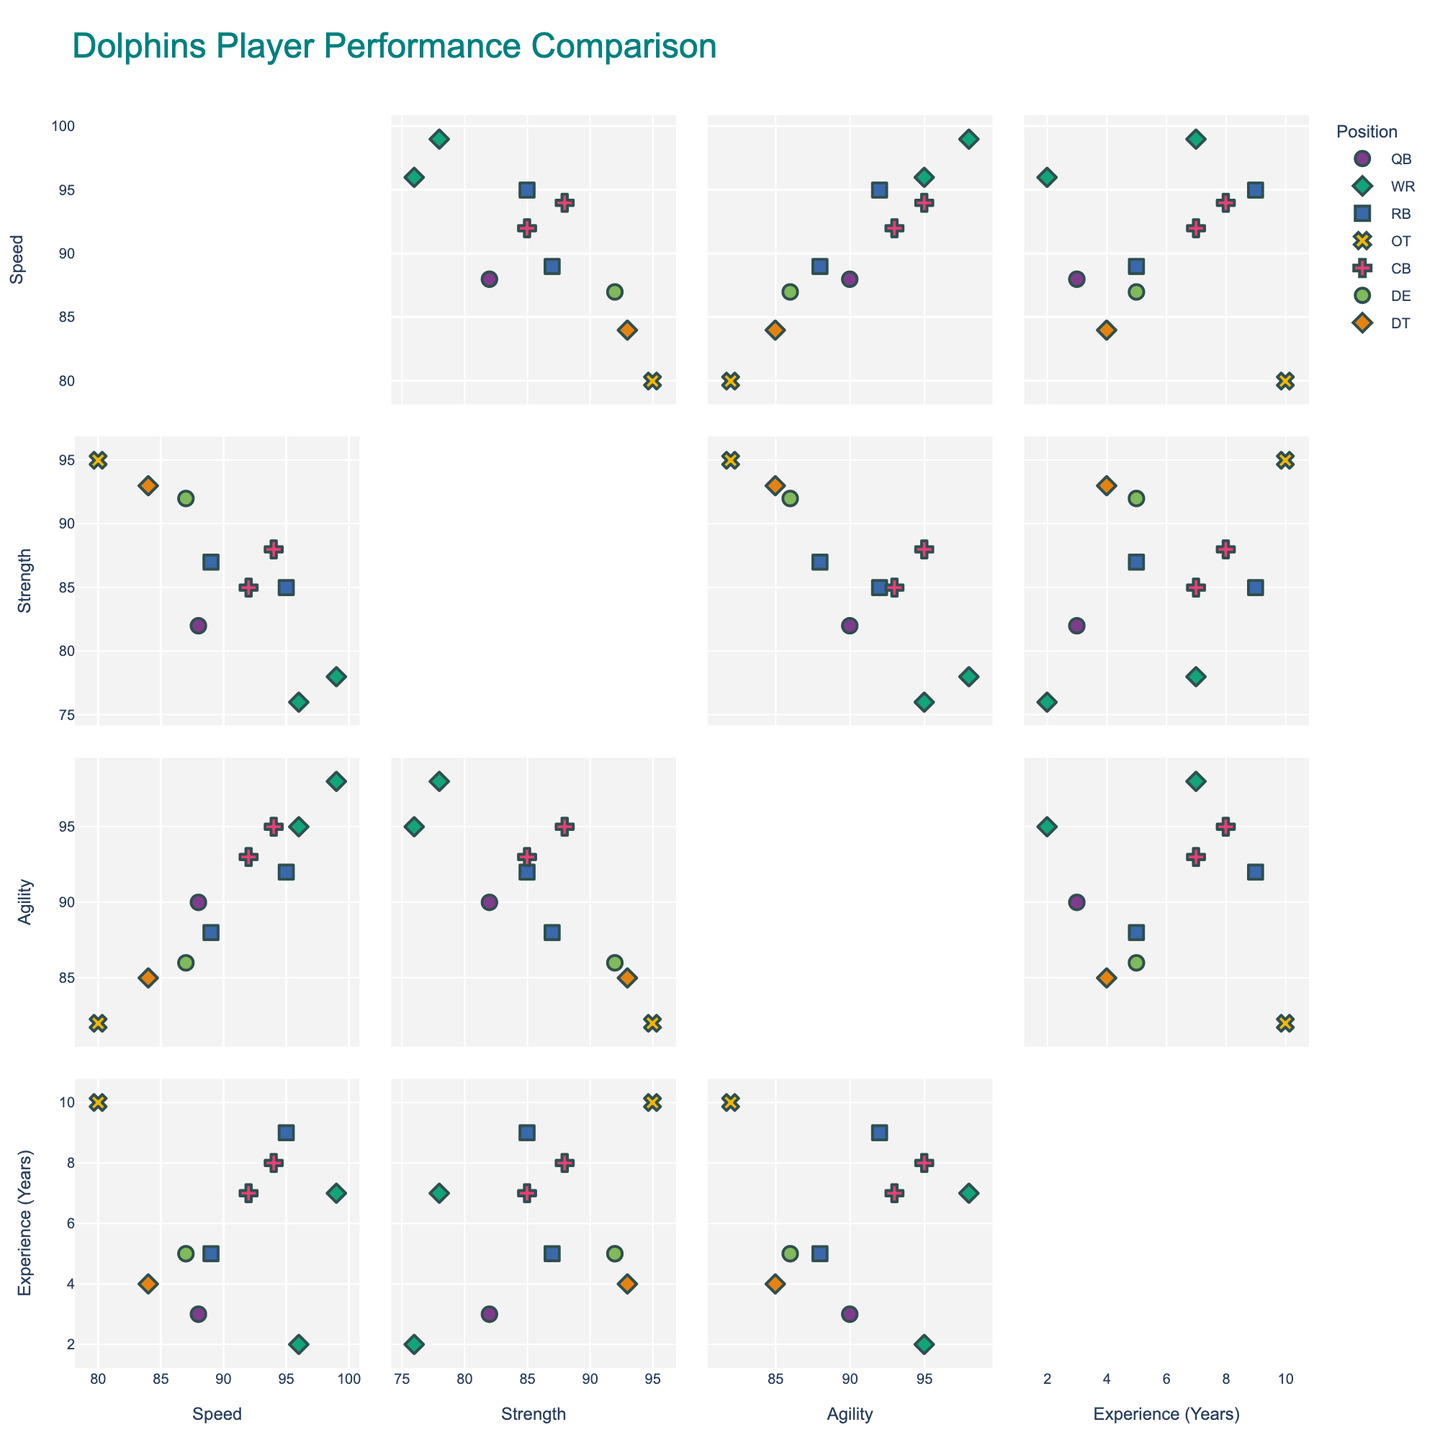What is the title of the figure? The title of the figure is usually found at the top, indicating what the plot is depicting. In this case, it is "Dolphins Player Performance Comparison".
Answer: Dolphins Player Performance Comparison How many positional groups are included in the figure? By observing the color and symbol legends in the plot, we can count the number of distinct positional groups represented.
Answer: 5 Who has the highest speed attribute, and what is their position? Identify the highest value on the Speed axis, then locate the corresponding data point and check the associated Player and Position from the hover data or legend.
Answer: Tyreek Hill, WR Which player has the most experience, and what value of agility do they have? Find the player with the highest experience value along the Experience axis and then look at their corresponding agility value.
Answer: Terron Armstead, 82 What is the average strength value for wide receivers (WR)? Locate all WR data points, sum their strength values (78 and 76), and divide by the number of WRs (2). (78 + 76) / 2 = 154 / 2 = 77
Answer: 77 Which player displays higher agility, Jaylen Waddle or Christian Wilkins? Compare the agility values of both players directly from the plot annotations or hover data.
Answer: Jaylen Waddle Compare the agility of Jalen Ramsey and Raheem Mostert. Who has the higher value and by how much? Identify the agility values for both players, then subtract the smaller value from the larger one. Ramsey: 95, Mostert: 92. 95 - 92 = 3
Answer: Jalen Ramsey, by 3 How does the range of experience compare between running backs (RB) and cornerbacks (CB)? Identify the minimum and maximum experience values for RBs and CBs, then calculate the range for each position. RB: (5, 9), range = 9 - 5 = 4. CB: (7, 8), range = 8 - 7 = 1
Answer: RB: 4, CB: 1 Which player has the closest combination of speed and strength values, and what are those values? Find the player whose speed and strength values are nearest to each other by comparing the two axes for each data point.
Answer: Tua Tagovailoa, Speed: 88, Strength: 82 